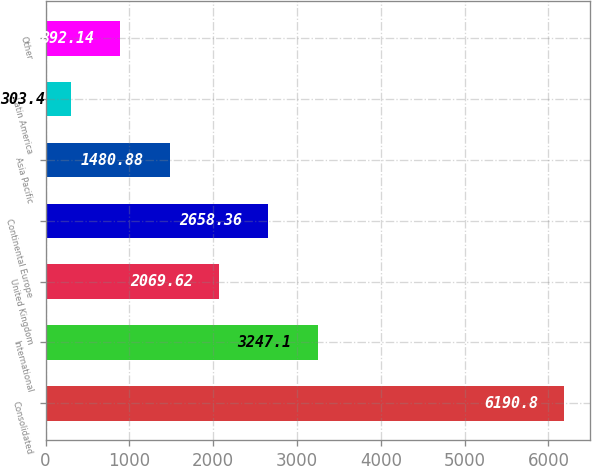Convert chart. <chart><loc_0><loc_0><loc_500><loc_500><bar_chart><fcel>Consolidated<fcel>International<fcel>United Kingdom<fcel>Continental Europe<fcel>Asia Pacific<fcel>Latin America<fcel>Other<nl><fcel>6190.8<fcel>3247.1<fcel>2069.62<fcel>2658.36<fcel>1480.88<fcel>303.4<fcel>892.14<nl></chart> 